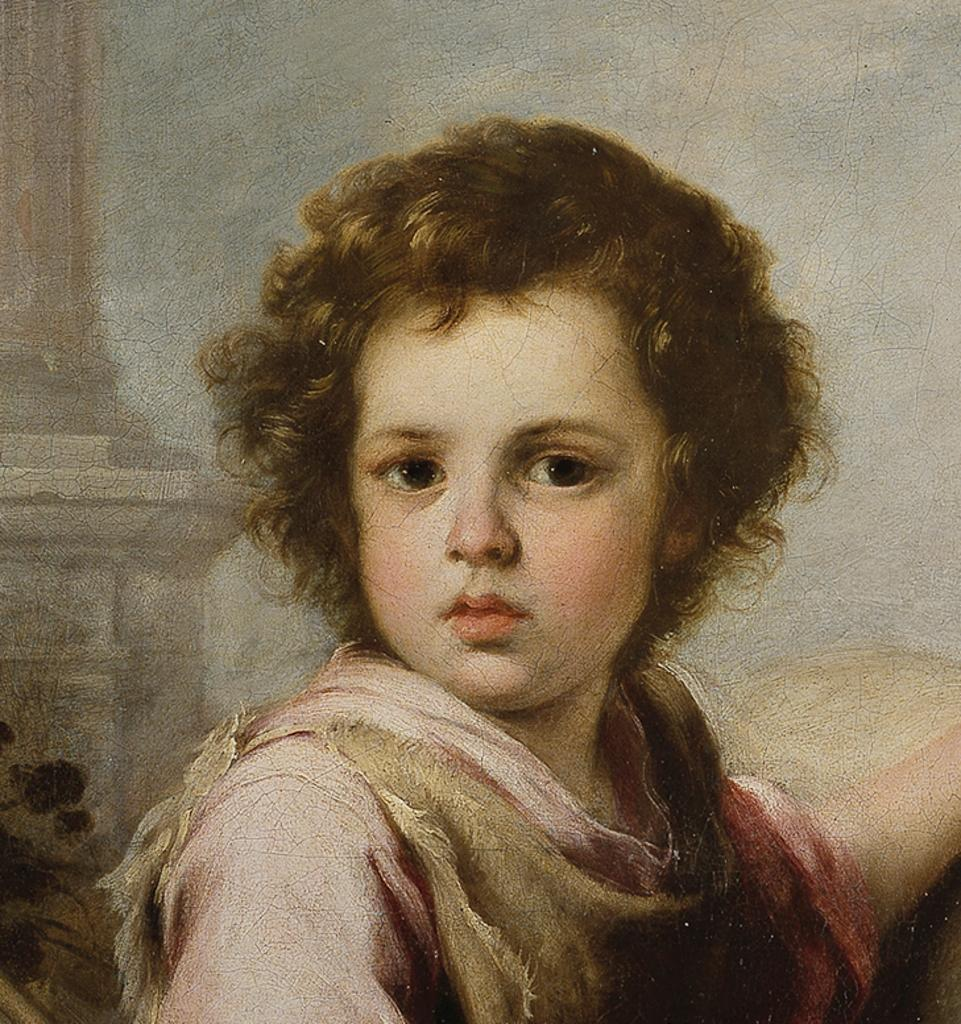What is the main subject of the painting in the image? The main subject of the painting in the image is a kid. What type of engine is depicted in the painting? There is no engine depicted in the painting; it features a kid as the main subject. What route is the kid taking in the painting? The painting does not depict a route or any movement; it is a static representation of a kid. 